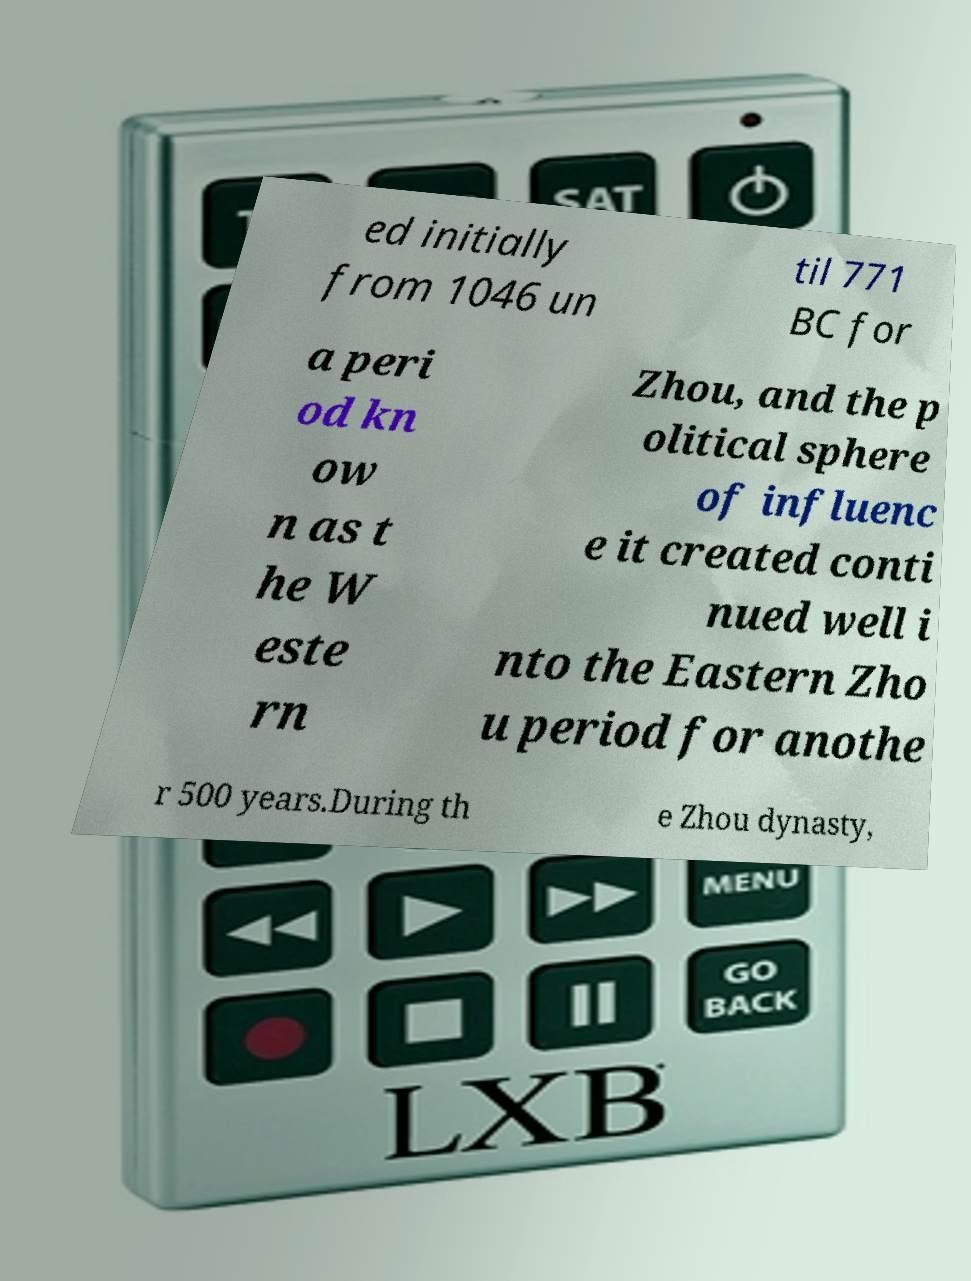Please read and relay the text visible in this image. What does it say? ed initially from 1046 un til 771 BC for a peri od kn ow n as t he W este rn Zhou, and the p olitical sphere of influenc e it created conti nued well i nto the Eastern Zho u period for anothe r 500 years.During th e Zhou dynasty, 